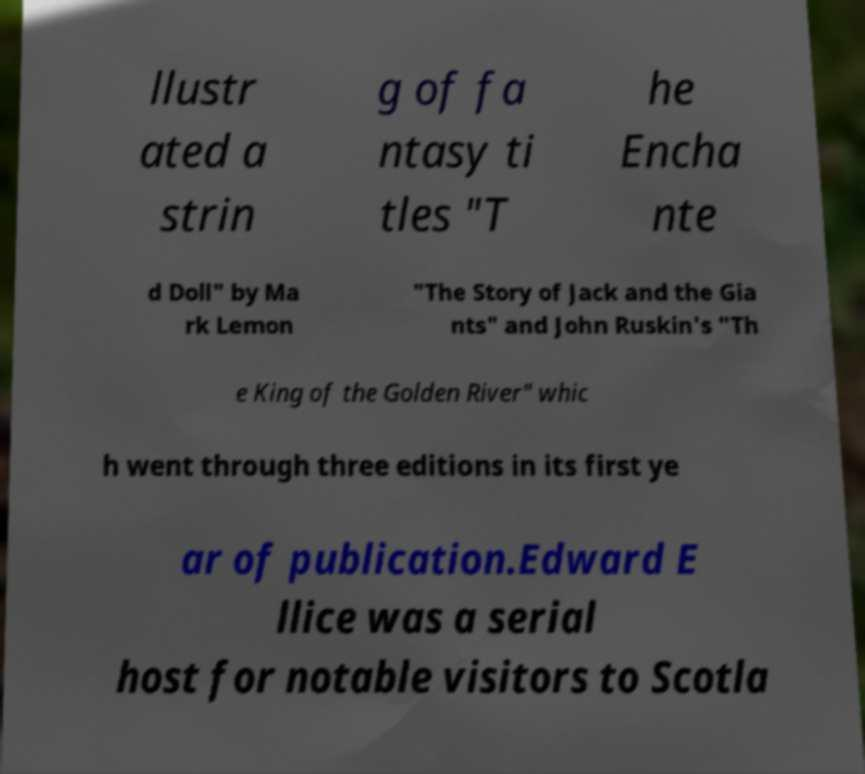Can you accurately transcribe the text from the provided image for me? llustr ated a strin g of fa ntasy ti tles "T he Encha nte d Doll" by Ma rk Lemon "The Story of Jack and the Gia nts" and John Ruskin's "Th e King of the Golden River" whic h went through three editions in its first ye ar of publication.Edward E llice was a serial host for notable visitors to Scotla 